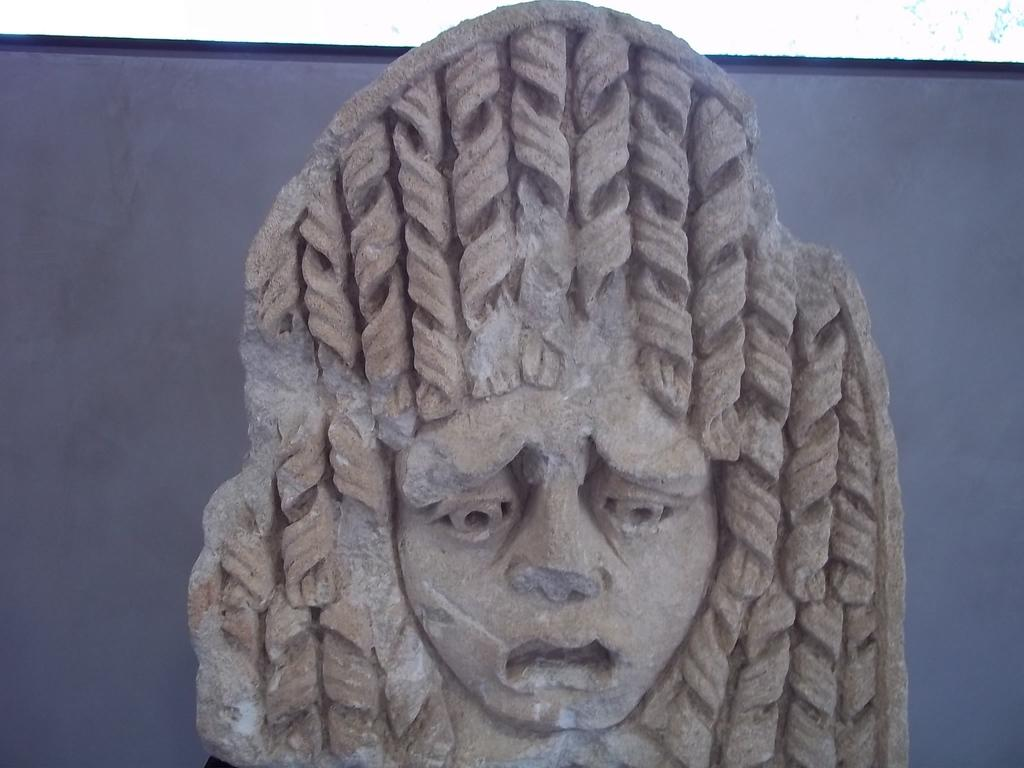What is the main subject in the center of the image? There is a statue in the center of the image. What type of apparatus is being used by the squirrel in the image? There is no squirrel present in the image, and therefore no apparatus being used. What is the condition of the statue's knee in the image? The statue does not have a knee, as it is an inanimate object. 